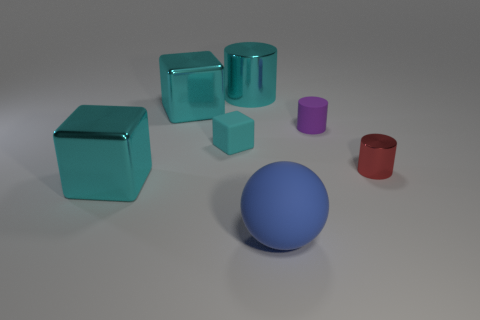There is a cyan metal block that is behind the metallic thing that is on the right side of the big cyan cylinder; how many red metal objects are left of it? In the image, I can see various objects in different colors and shapes. There are no red metal objects left of the cyan block that is positioned behind the metallic item on the right side of the large cyan cylinder. Therefore, the accurate count of red metal objects in that specific area is zero. 